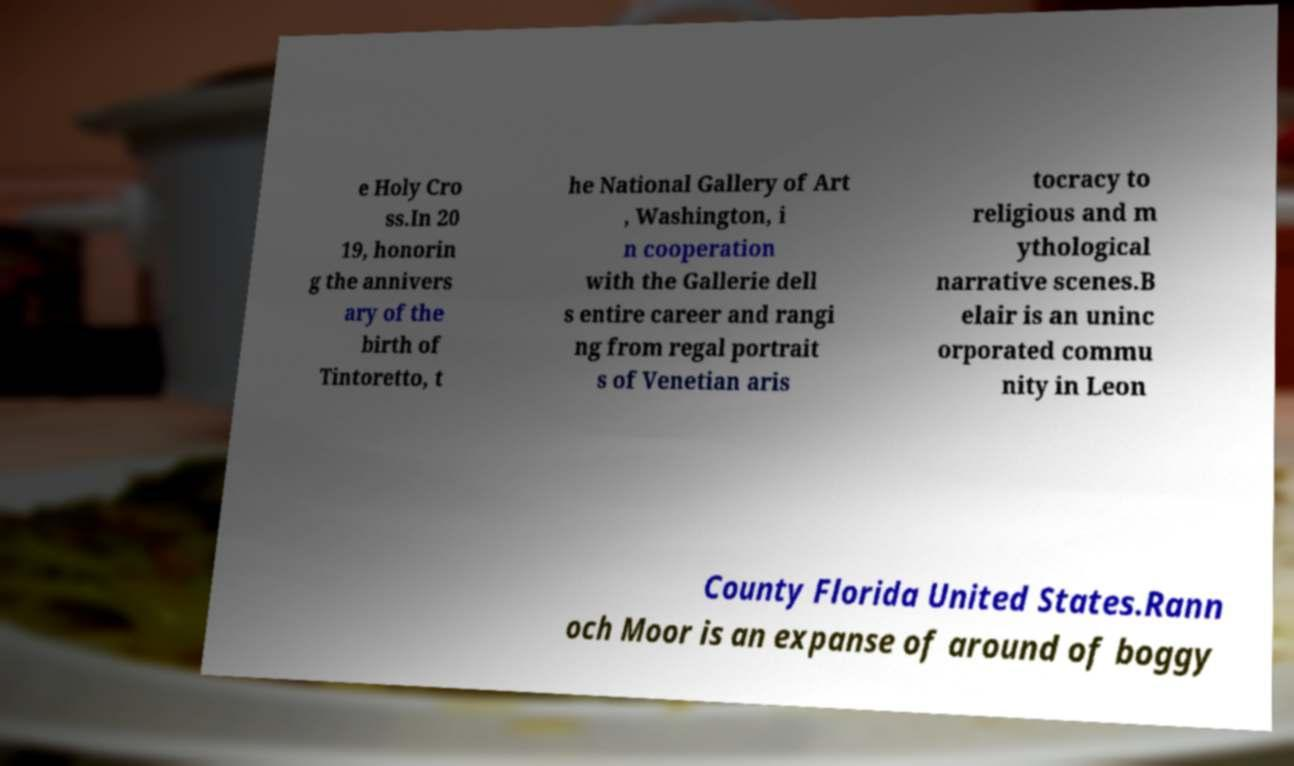There's text embedded in this image that I need extracted. Can you transcribe it verbatim? e Holy Cro ss.In 20 19, honorin g the annivers ary of the birth of Tintoretto, t he National Gallery of Art , Washington, i n cooperation with the Gallerie dell s entire career and rangi ng from regal portrait s of Venetian aris tocracy to religious and m ythological narrative scenes.B elair is an uninc orporated commu nity in Leon County Florida United States.Rann och Moor is an expanse of around of boggy 